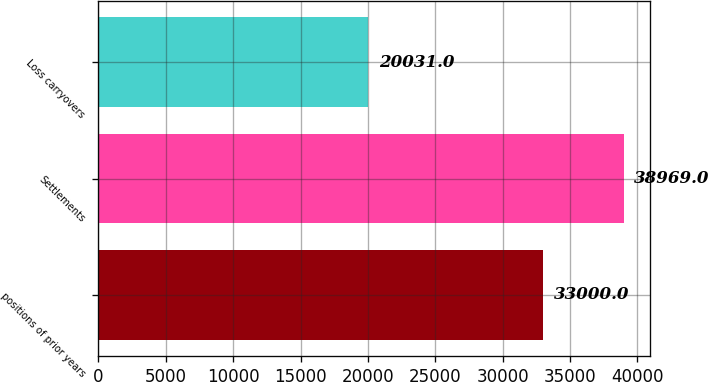<chart> <loc_0><loc_0><loc_500><loc_500><bar_chart><fcel>positions of prior years<fcel>Settlements<fcel>Loss carryovers<nl><fcel>33000<fcel>38969<fcel>20031<nl></chart> 